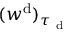Convert formula to latex. <formula><loc_0><loc_0><loc_500><loc_500>( w ^ { d } ) _ { \tau _ { d } }</formula> 